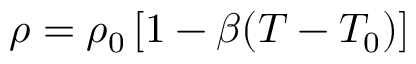<formula> <loc_0><loc_0><loc_500><loc_500>\rho = \rho _ { 0 } \left [ 1 - \beta ( T - T _ { 0 } ) \right ]</formula> 